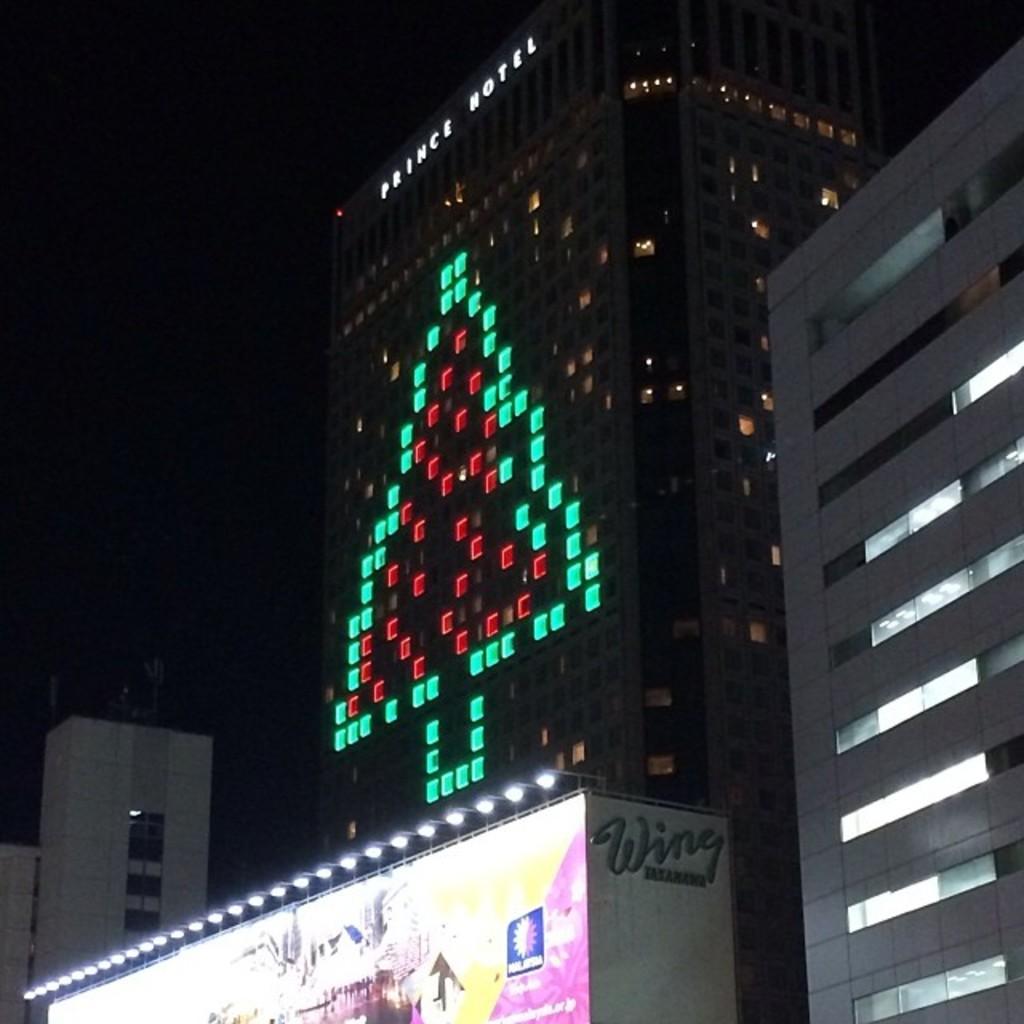How would you summarize this image in a sentence or two? This picture shows few buildings and we see lights. 